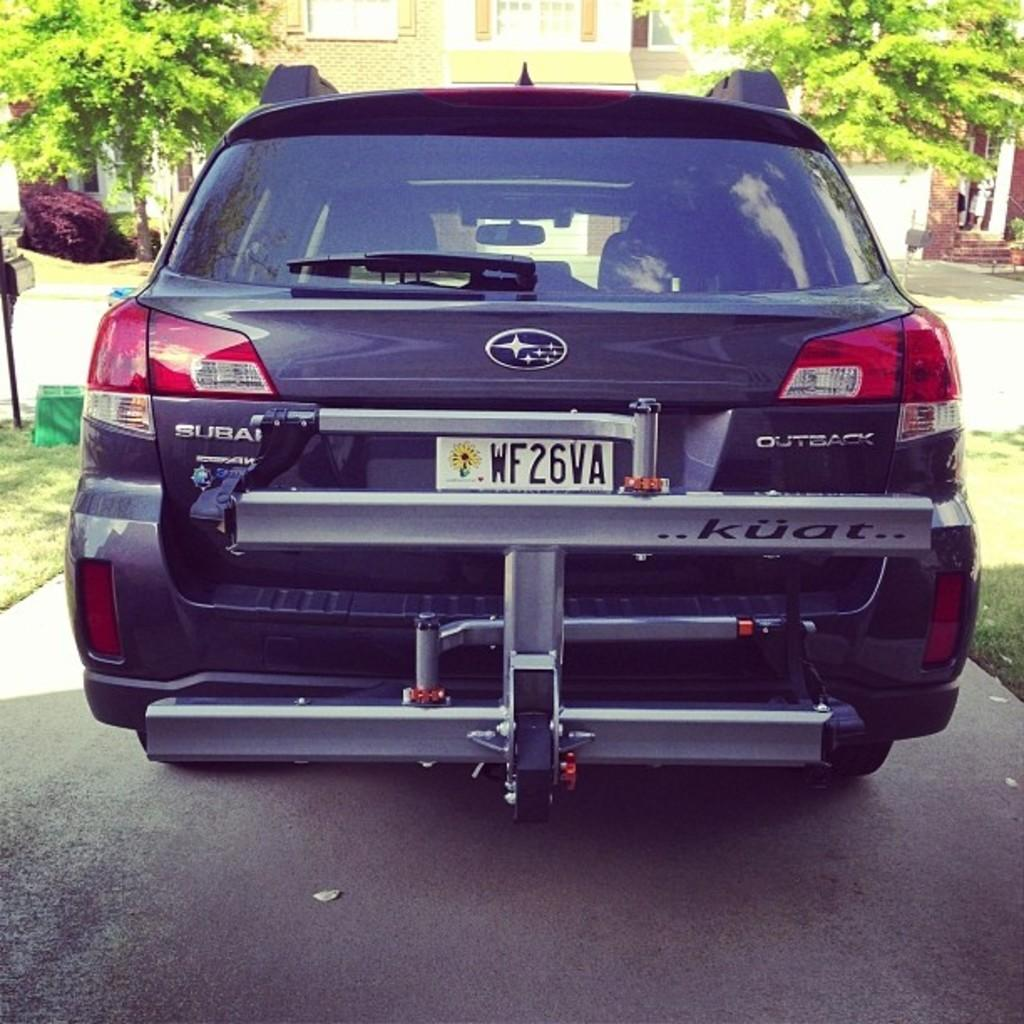<image>
Create a compact narrative representing the image presented. back up shot of a suburu outback with large trailer hitch 